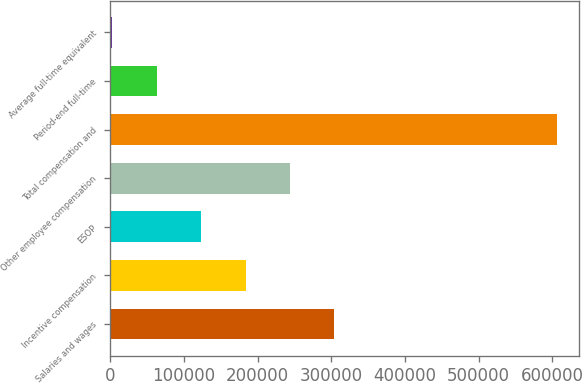<chart> <loc_0><loc_0><loc_500><loc_500><bar_chart><fcel>Salaries and wages<fcel>Incentive compensation<fcel>ESOP<fcel>Other employee compensation<fcel>Total compensation and<fcel>Period-end full-time<fcel>Average full-time equivalent<nl><fcel>304399<fcel>183598<fcel>123197<fcel>243998<fcel>606402<fcel>62796.6<fcel>2396<nl></chart> 